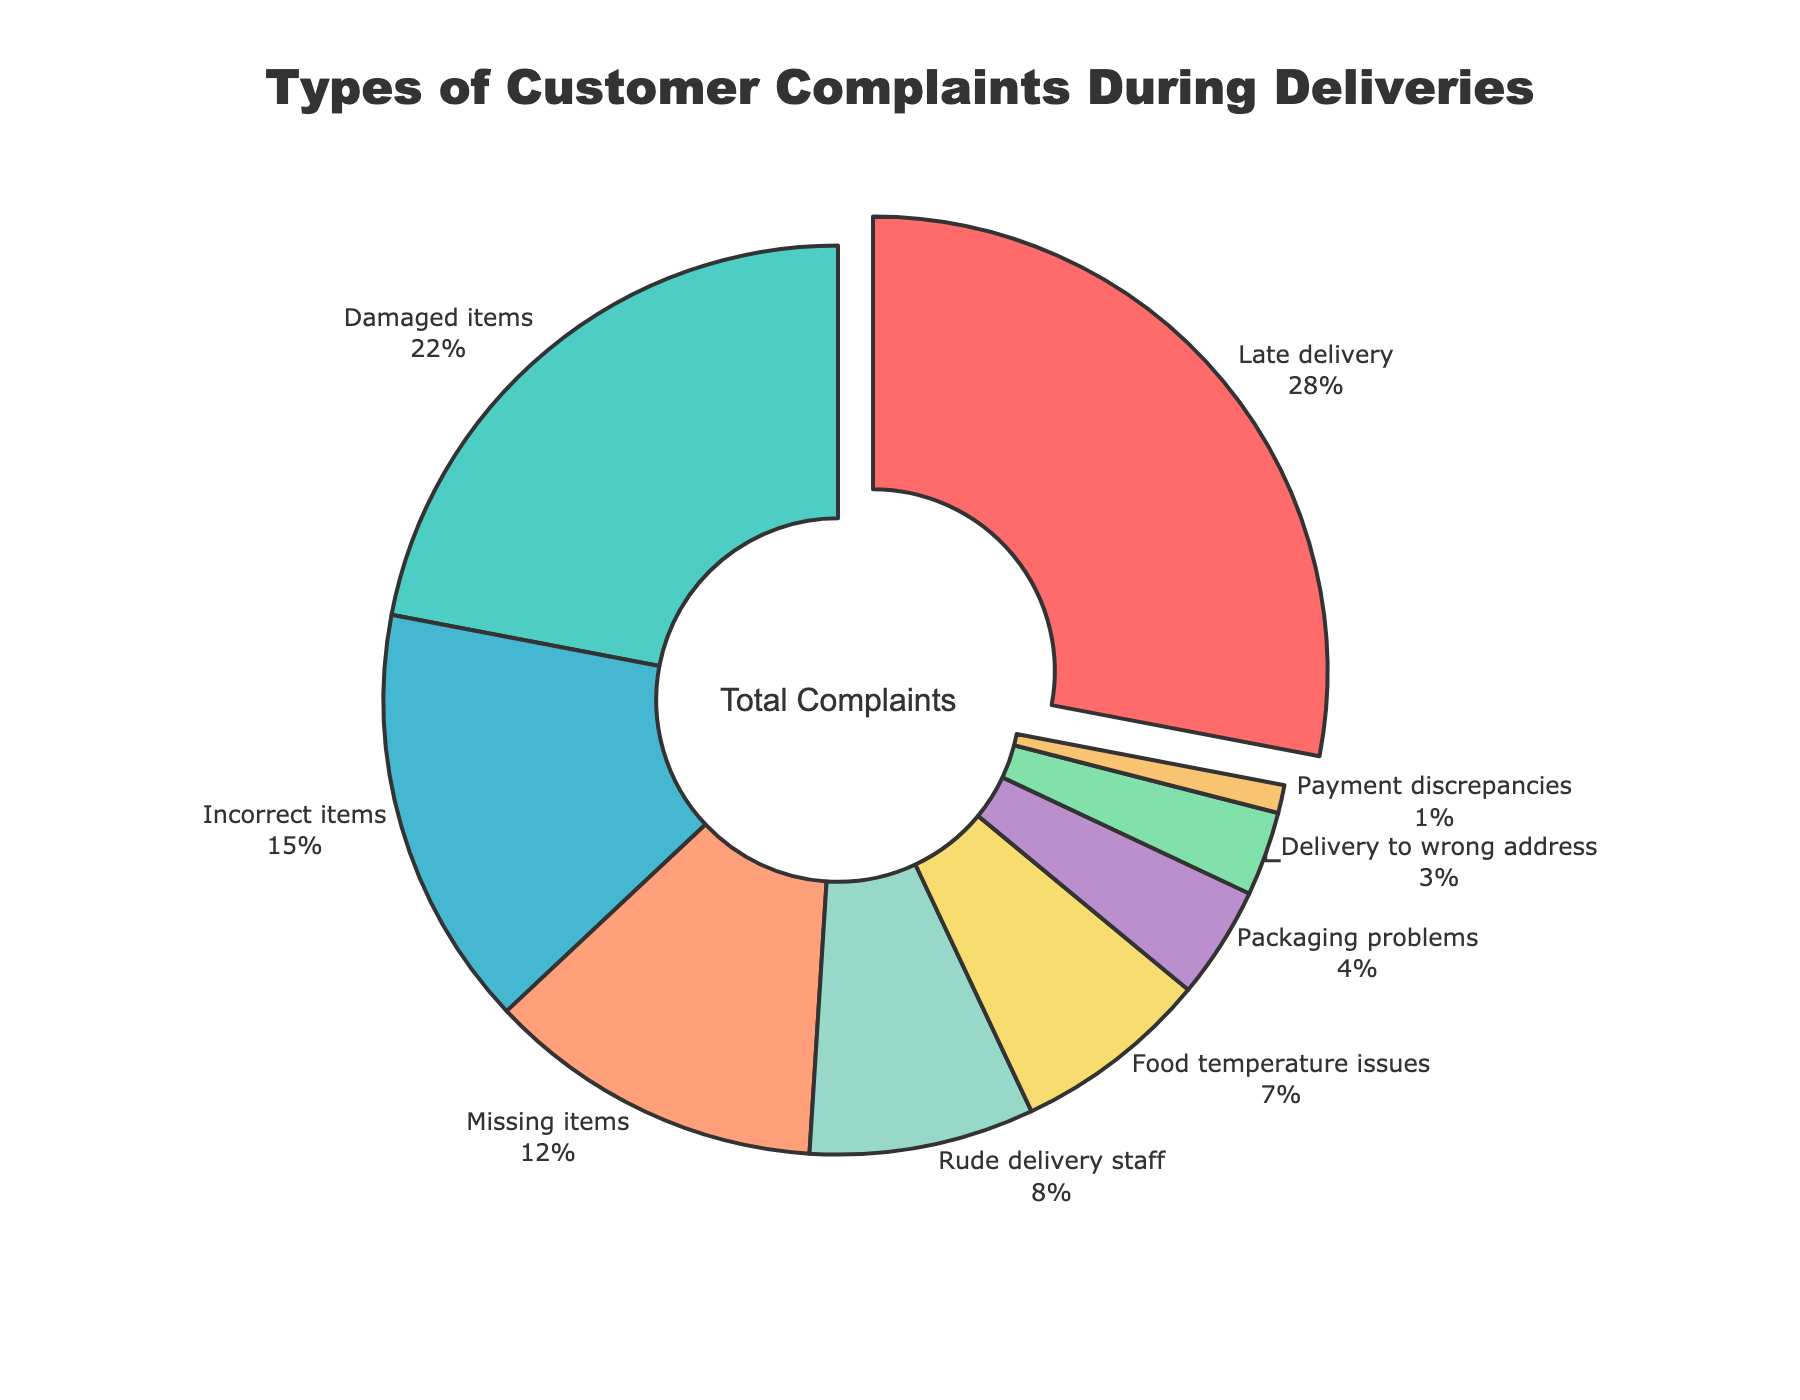What's the most common type of customer complaint during deliveries? The pie chart indicates that 'Late delivery' has the largest segment, which means it is the most common complaint.
Answer: Late delivery Which two categories combined make up 50% of the complaints? Adding the percentages of the two largest categories: 'Late delivery' (28%) and 'Damaged items' (22%) gives us 28% + 22% = 50%.
Answer: Late delivery and Damaged items How much more common are late deliveries compared to incorrect items? The percentage for 'Late delivery' is 28% and for 'Incorrect items' is 15%. The difference is 28% - 15% = 13%.
Answer: 13% What percentage of the complaints are related to items being incorrect or missing? Adding the percentages for 'Incorrect items' (15%) and 'Missing items' (12%): 15% + 12% = 27%.
Answer: 27% Which category has the smallest percentage of complaints? The pie chart shows that 'Payment discrepancies' has the smallest segment, which indicates it has the least complaints.
Answer: Payment discrepancies How do complaints about rude delivery staff compare to food temperature issues? The percentage for 'Rude delivery staff' is 8% and for 'Food temperature issues' is 7%. 8% is slightly higher than 7%.
Answer: Rude delivery staff is 1% more common What is the combined percentage of complaints related to delivery errors (Late delivery, Delivery to wrong address)? Adding the percentages for 'Late delivery' (28%) and 'Delivery to wrong address' (3%): 28% + 3% = 31%.
Answer: 31% Which categories are less common than food temperature issues? The pie chart shows 'Packaging problems' (4%), 'Delivery to wrong address' (3%), and 'Payment discrepancies' (1%) all have smaller percentages than 'Food temperature issues' (7%).
Answer: Packaging problems, Delivery to wrong address, Payment discrepancies If the total number of complaints is 500, how many complaints are due to missing items? The percentage for 'Missing items' is 12%. To find the number of complaints: 500 * 0.12 = 60.
Answer: 60 What visual feature highlights the most common complaint category? The pie chart uses a pulled-out segment to emphasize 'Late delivery' as the most common complaint category.
Answer: Pulled-out segment 